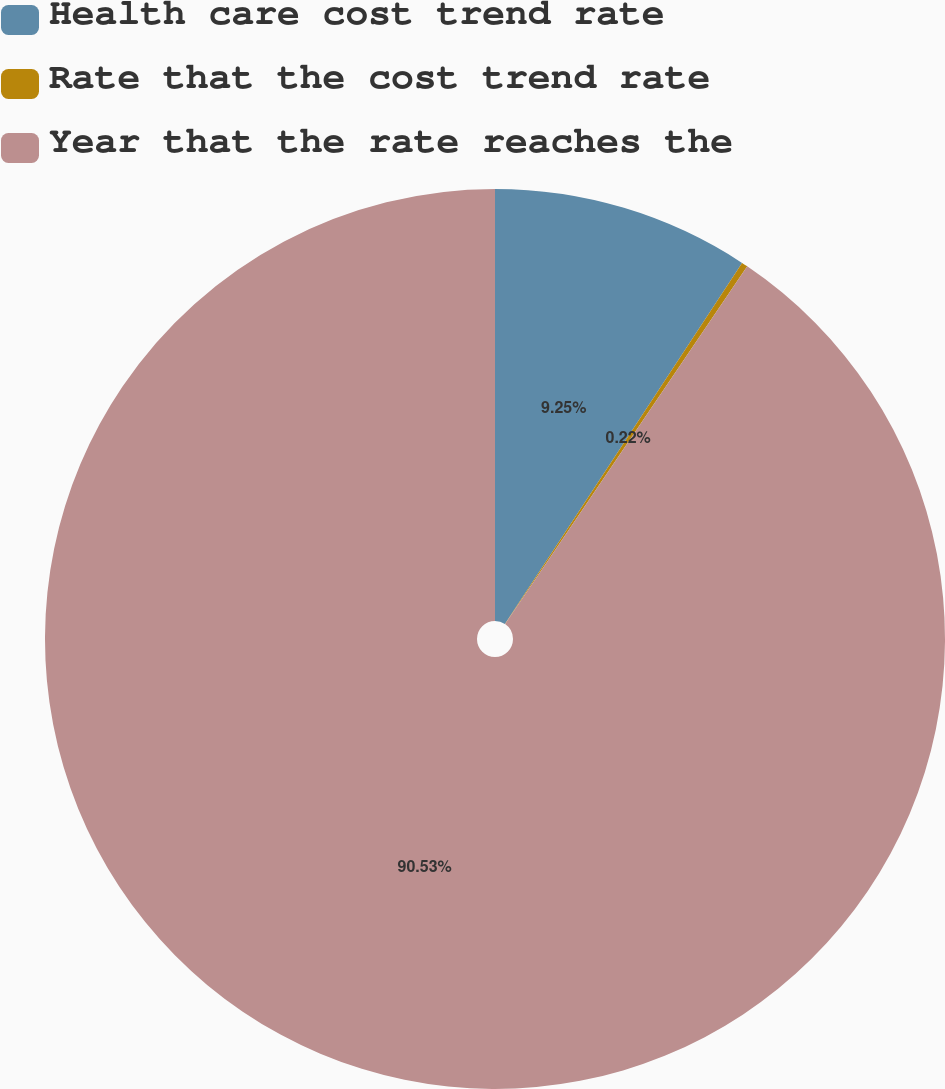<chart> <loc_0><loc_0><loc_500><loc_500><pie_chart><fcel>Health care cost trend rate<fcel>Rate that the cost trend rate<fcel>Year that the rate reaches the<nl><fcel>9.25%<fcel>0.22%<fcel>90.52%<nl></chart> 